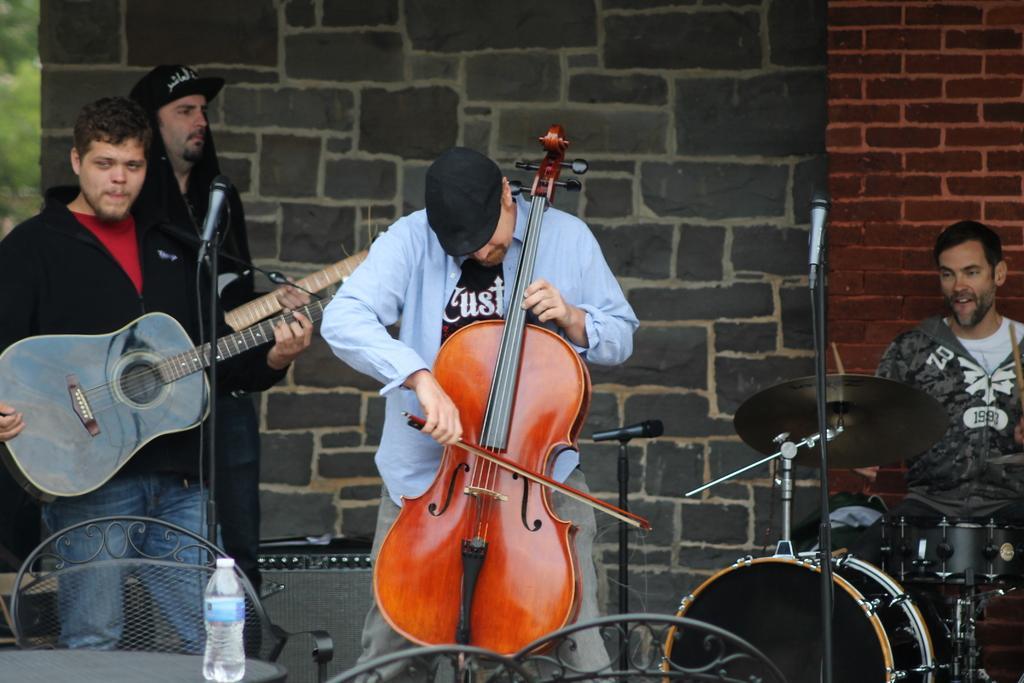Please provide a concise description of this image. In this picture we can see four persons playing musical instruments such as guitar, violin, drums and in front of them there are chairs,table, bottle and in background we can see wall. 